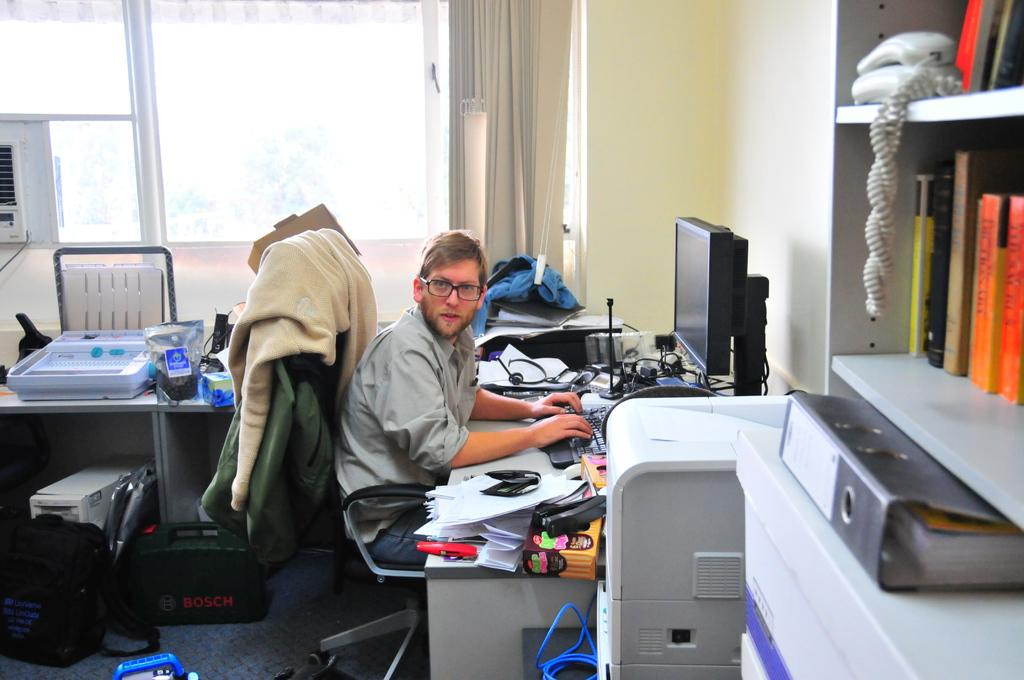What is the man in the image doing? The man is sitting on a chair in the image. What is on the table in the image? There is a system and paper on the table in the image. What else can be seen on the table in the image? There are objects on the table in the image. Where is the bag located in the image? The bag is on the floor in the image. What type of sticks are used for the acoustics in the image? There are no sticks or acoustics present in the image. What type of shoes is the man wearing in the image? The image does not show the man's shoes, so it cannot be determined from the image. 